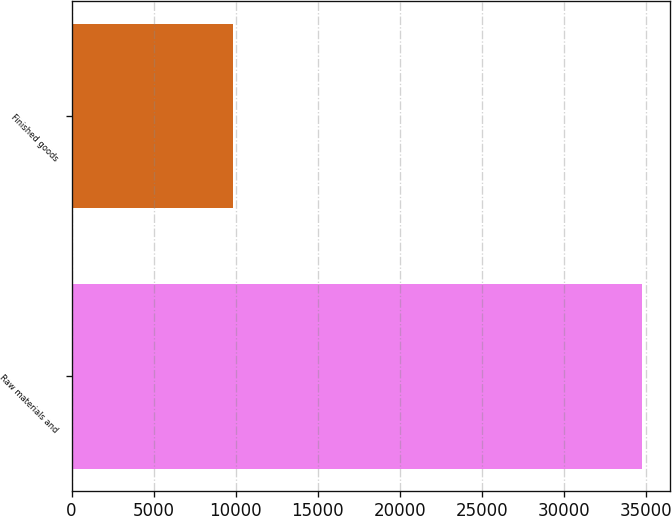Convert chart to OTSL. <chart><loc_0><loc_0><loc_500><loc_500><bar_chart><fcel>Raw materials and<fcel>Finished goods<nl><fcel>34714<fcel>9806<nl></chart> 